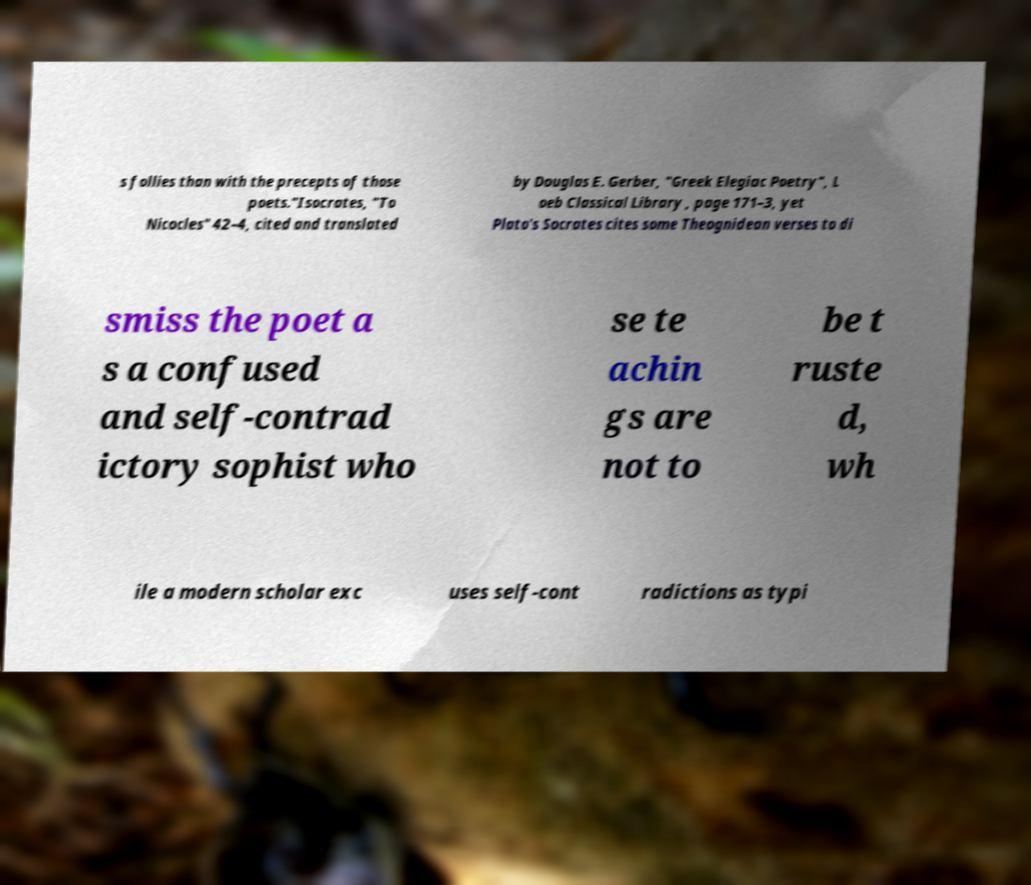Please read and relay the text visible in this image. What does it say? s follies than with the precepts of those poets."Isocrates, "To Nicocles" 42–4, cited and translated by Douglas E. Gerber, "Greek Elegiac Poetry", L oeb Classical Library , page 171–3, yet Plato's Socrates cites some Theognidean verses to di smiss the poet a s a confused and self-contrad ictory sophist who se te achin gs are not to be t ruste d, wh ile a modern scholar exc uses self-cont radictions as typi 